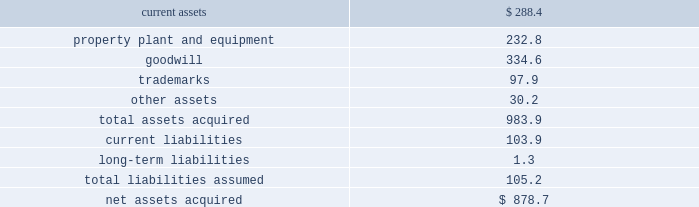492010 annual report consolidation 2013 effective february 28 , 2010 , the company adopted the fasb amended guidance for con- solidation .
This guidance clarifies that the scope of the decrease in ownership provisions applies to the follow- ing : ( i ) a subsidiary or group of assets that is a business or nonprofit activity ; ( ii ) a subsidiary that is a business or nonprofit activity that is transferred to an equity method investee or joint venture ; and ( iii ) an exchange of a group of assets that constitutes a business or nonprofit activ- ity for a noncontrolling interest in an entity ( including an equity method investee or joint venture ) .
This guidance also expands the disclosures about the deconsolidation of a subsidiary or derecognition of a group of assets within the scope of the guidance .
The adoption of this guidance did not have a material impact on the company 2019s consolidated financial statements .
3 . acquisitions : acquisition of bwe 2013 on december 17 , 2007 , the company acquired all of the issued and outstanding capital stock of beam wine estates , inc .
( 201cbwe 201d ) , an indirect wholly-owned subsidiary of fortune brands , inc. , together with bwe 2019s subsidiaries : atlas peak vineyards , inc. , buena vista winery , inc. , clos du bois , inc. , gary farrell wines , inc .
And peak wines international , inc .
( the 201cbwe acquisition 201d ) .
As a result of the bwe acquisition , the company acquired the u.s .
Wine portfolio of fortune brands , inc. , including certain wineries , vineyards or inter- ests therein in the state of california , as well as various super-premium and fine california wine brands including clos du bois and wild horse .
The bwe acquisition sup- ports the company 2019s strategy of strengthening its portfolio with fast-growing super-premium and above wines .
The bwe acquisition strengthens the company 2019s position as the leading wine company in the world and the leading premium wine company in the u.s .
Total consideration paid in cash was $ 877.3 million .
In addition , the company incurred direct acquisition costs of $ 1.4 million .
The purchase price was financed with the net proceeds from the company 2019s december 2007 senior notes ( as defined in note 11 ) and revolver borrowings under the company 2019s june 2006 credit agreement , as amended in february 2007 and november 2007 ( as defined in note 11 ) .
In accordance with the purchase method of accounting , the acquired net assets are recorded at fair value at the date of acquisition .
The purchase price was based primarily on the estimated future operating results of the bwe business , including the factors described above .
In june 2008 , the company sold certain businesses consisting of several of the california wineries and wine brands acquired in the bwe acquisition , as well as certain wineries and wine brands from the states of washington and idaho ( collectively , the 201cpacific northwest business 201d ) ( see note 7 ) .
The results of operations of the bwe business are reported in the constellation wines segment and are included in the consolidated results of operations of the company from the date of acquisition .
The table summarizes the fair values of the assets acquired and liabilities assumed in the bwe acquisition at the date of acquisition .
( in millions ) current assets $ 288.4 property , plant and equipment 232.8 .
Other assets 30.2 total assets acquired 983.9 current liabilities 103.9 long-term liabilities 1.3 total liabilities assumed 105.2 net assets acquired $ 878.7 the trademarks are not subject to amortization .
All of the goodwill is expected to be deductible for tax purposes .
Acquisition of svedka 2013 on march 19 , 2007 , the company acquired the svedka vodka brand ( 201csvedka 201d ) in connection with the acquisition of spirits marque one llc and related business ( the 201csvedka acquisition 201d ) .
Svedka is a premium swedish vodka .
At the time of the acquisition , the svedka acquisition supported the company 2019s strategy of expanding the company 2019s premium spirits business and provided a foundation from which the company looked to leverage its existing and future premium spirits portfolio for growth .
In addition , svedka complemented the company 2019s then existing portfolio of super-premium and value vodka brands by adding a premium vodka brand .
Total consideration paid in cash for the svedka acquisition was $ 385.8 million .
In addition , the company incurred direct acquisition costs of $ 1.3 million .
The pur- chase price was financed with revolver borrowings under the company 2019s june 2006 credit agreement , as amended in february 2007 .
In accordance with the purchase method of accounting , the acquired net assets are recorded at fair value at the date of acquisition .
The purchase price was based primarily on the estimated future operating results of the svedka business , including the factors described above .
The results of operations of the svedka business are reported in the constellation wines segment and are included in the consolidated results of operations of the company from the date of acquisition. .
What is the current ratio for bwe at the time of the acquisition? 
Computations: (288.4 / 103.9)
Answer: 2.77575. 